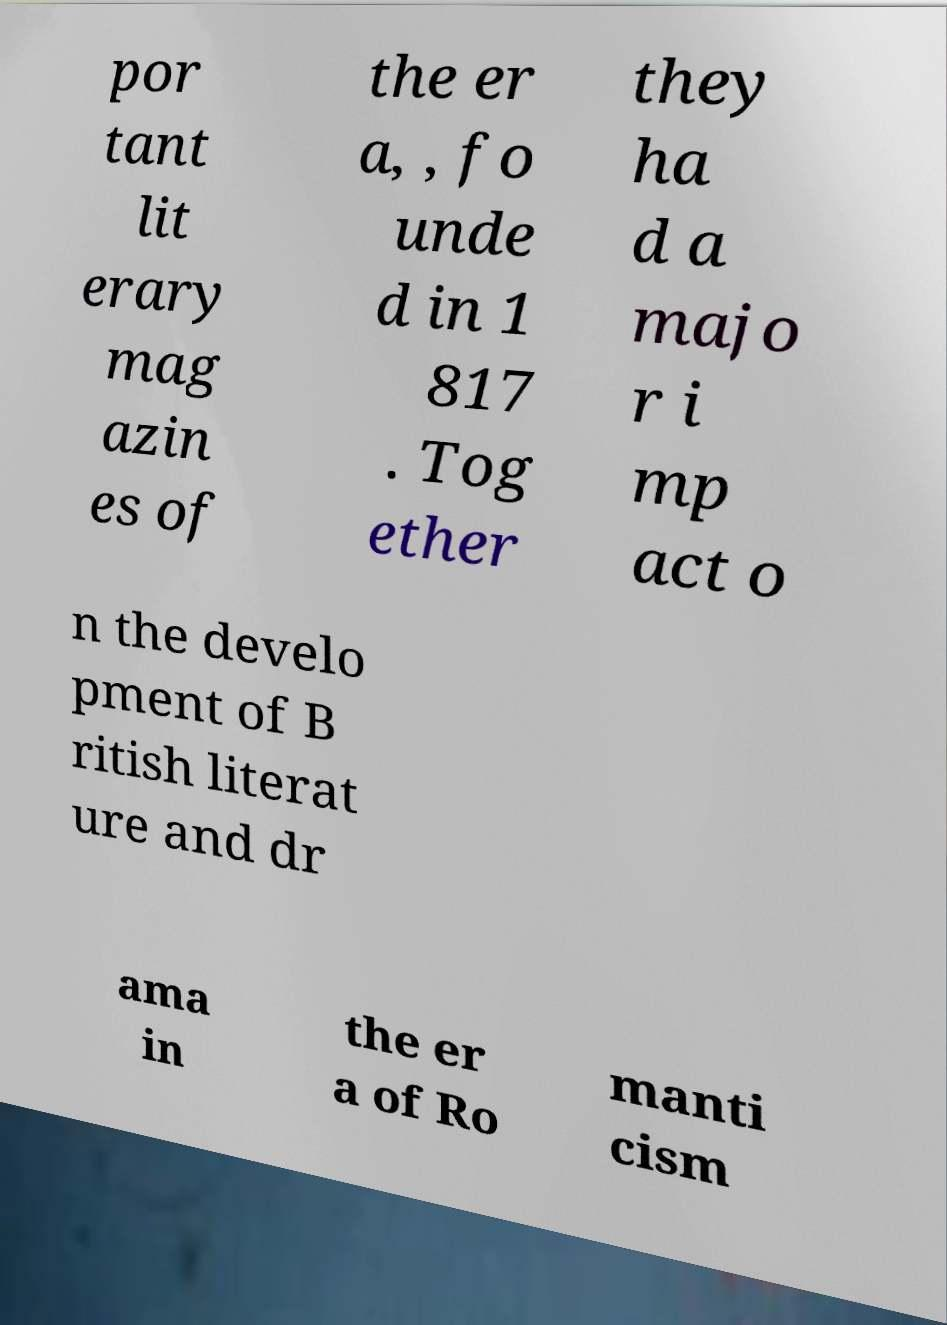Please read and relay the text visible in this image. What does it say? por tant lit erary mag azin es of the er a, , fo unde d in 1 817 . Tog ether they ha d a majo r i mp act o n the develo pment of B ritish literat ure and dr ama in the er a of Ro manti cism 